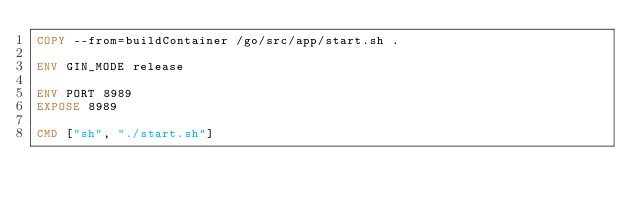Convert code to text. <code><loc_0><loc_0><loc_500><loc_500><_Dockerfile_>COPY --from=buildContainer /go/src/app/start.sh .

ENV GIN_MODE release

ENV PORT 8989
EXPOSE 8989

CMD ["sh", "./start.sh"]
</code> 